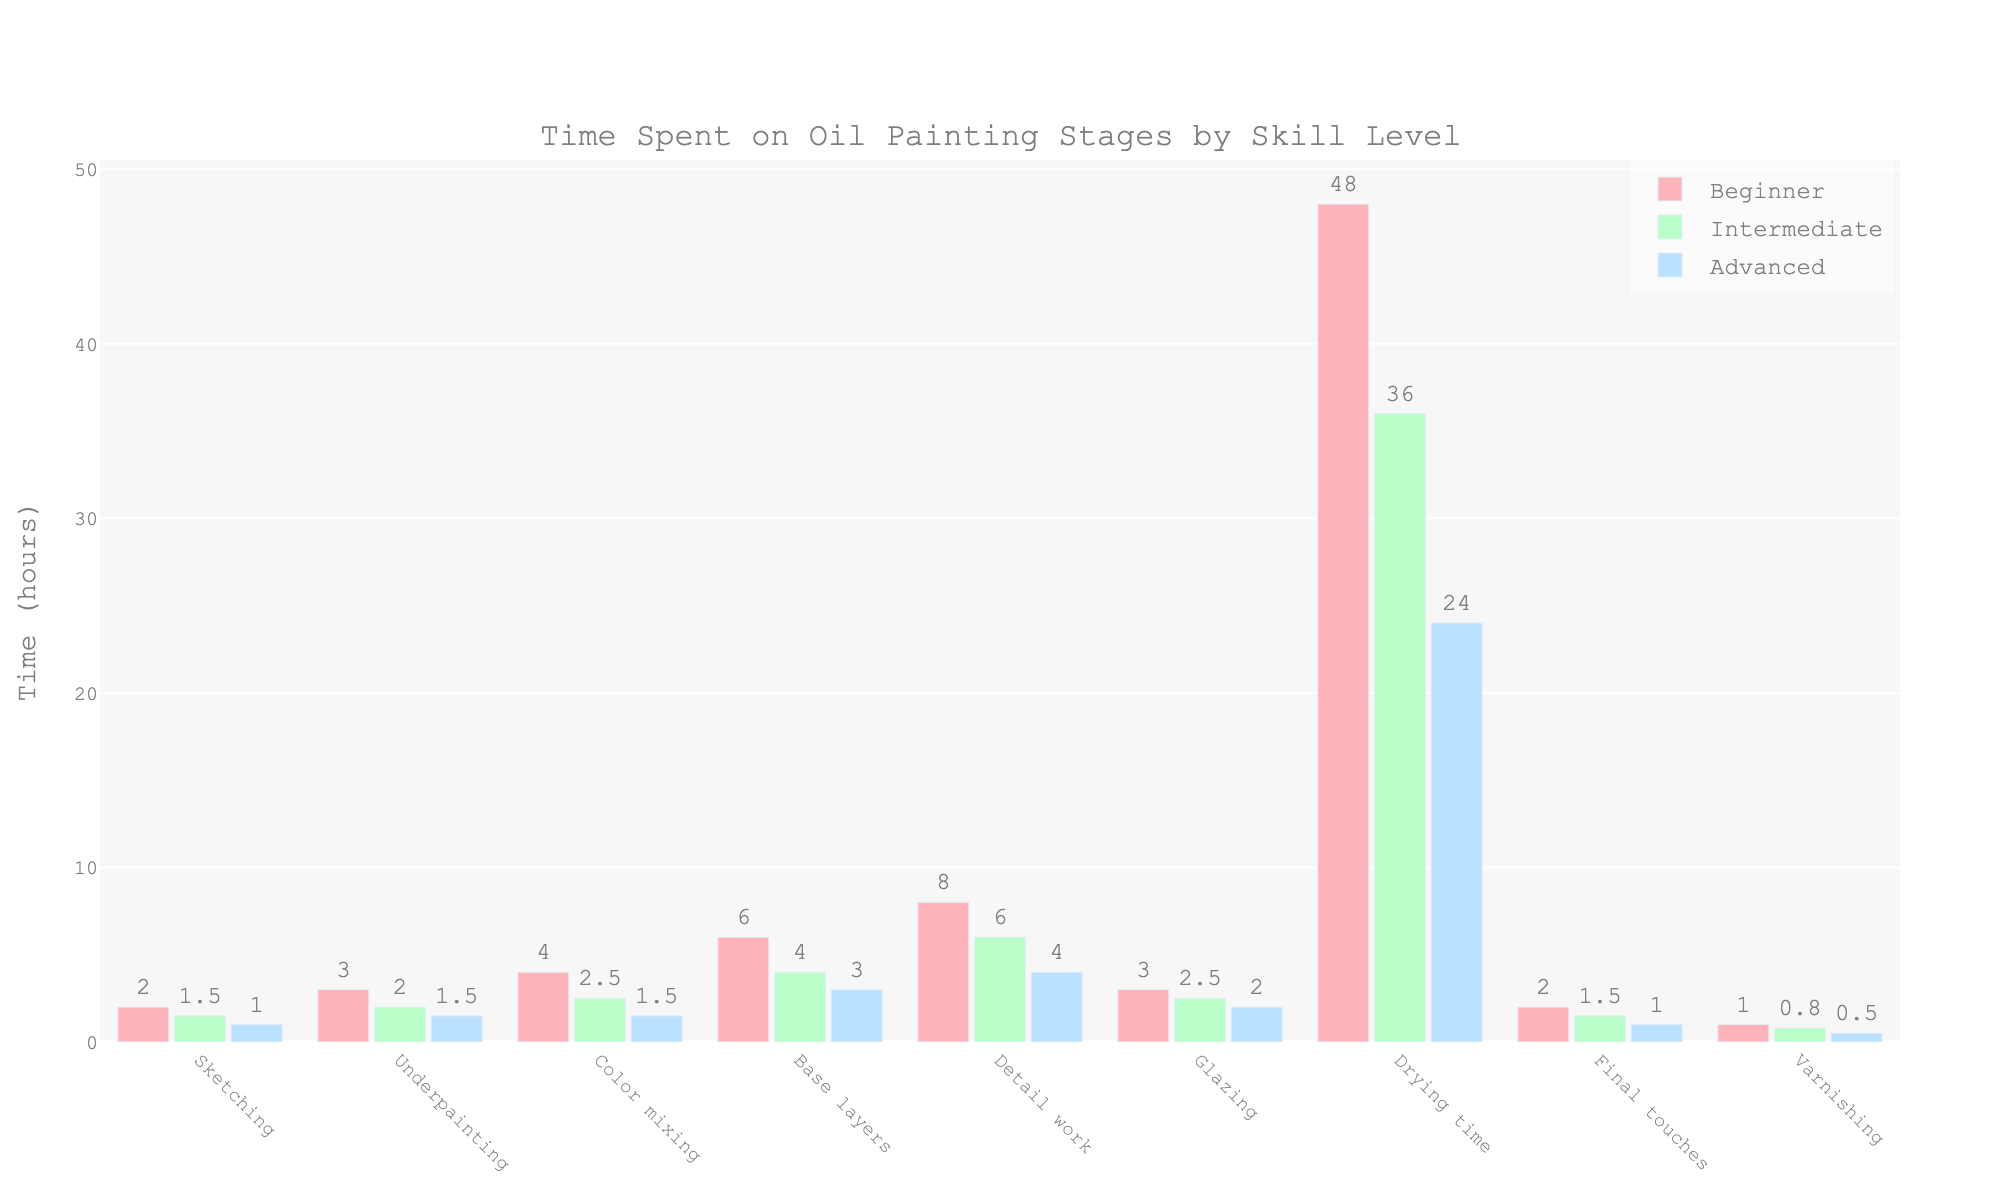How much more time do beginners spend on drying compared to intermediates? Beginners spend 48 hours drying, while intermediates spend 36 hours. The difference is 48 - 36.
Answer: 12 hours Which stage takes the longest time for advanced artists to complete? For advanced artists, the Detail work stage takes the longest at 4 hours.
Answer: Detail work What is the combined time beginners spend on underpainting, color mixing, and base layers? Beginners spend 3 hours on underpainting, 4 hours on color mixing, and 6 hours on base layers. The combined time is 3 + 4 + 6.
Answer: 13 hours Which skill level spends the least amount of time on final touches? Advanced artists spend the least amount of time on final touches, at 1 hour.
Answer: Advanced Compare the time spent on sketching by beginners and advanced artists. How much time does each spend, and what's the difference? Beginners spend 2 hours sketching, while advanced artists spend 1 hour. The difference is 2 - 1.
Answer: Beginners: 2 hours, Advanced: 1 hour, Difference: 1 hour What is the average time spent on glazing across all skill levels? The times spent on glazing are 3 hours (Beginners), 2.5 hours (Intermediates), and 2 hours (Advanced). The average is (3 + 2.5 + 2) / 3.
Answer: 2.5 hours What stage do intermediates spend exactly 2.5 hours on? Intermediates spend exactly 2.5 hours on both Color mixing and Glazing stages.
Answer: Color mixing and Glazing What is the ratio of drying time between beginners and advanced artists? Beginners spend 48 hours on drying, advanced artists spend 24 hours. The ratio is 48/24.
Answer: 2:1 Which stage has the biggest time difference between beginners and advanced artists? The drying stage shows the biggest time difference. Beginners spend 48 hours, advanced artists spend 24 hours, the difference is 48 - 24.
Answer: Drying How do the times spent on varnishing compare between intermediates and advanced artists? Intermediates spend 0.8 hours on varnishing; advanced artists spend 0.5 hours. The difference is 0.8 - 0.5.
Answer: Intermediates: 0.8 hours, Advanced: 0.5 hours, Difference: 0.3 hours 